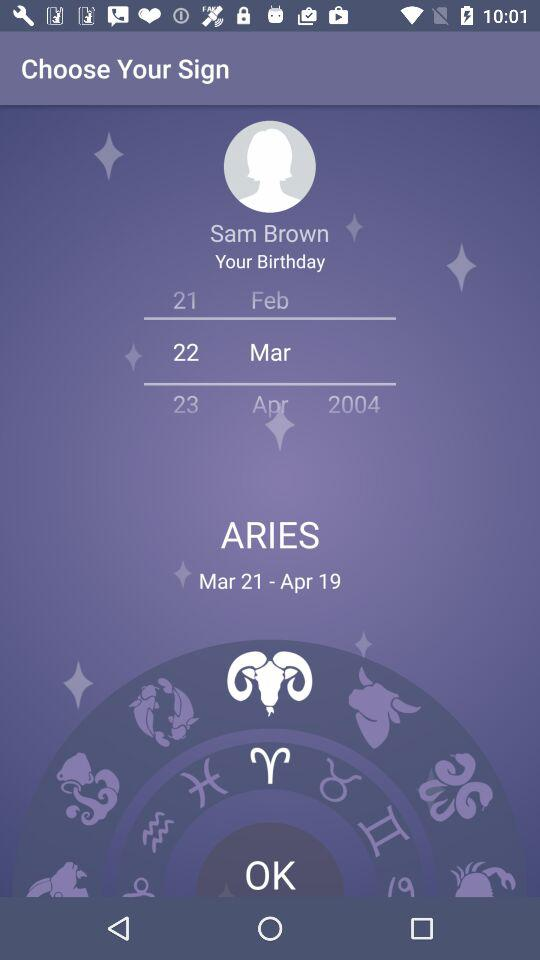Which birthdate is selected? The selected birthdate is March 22. 